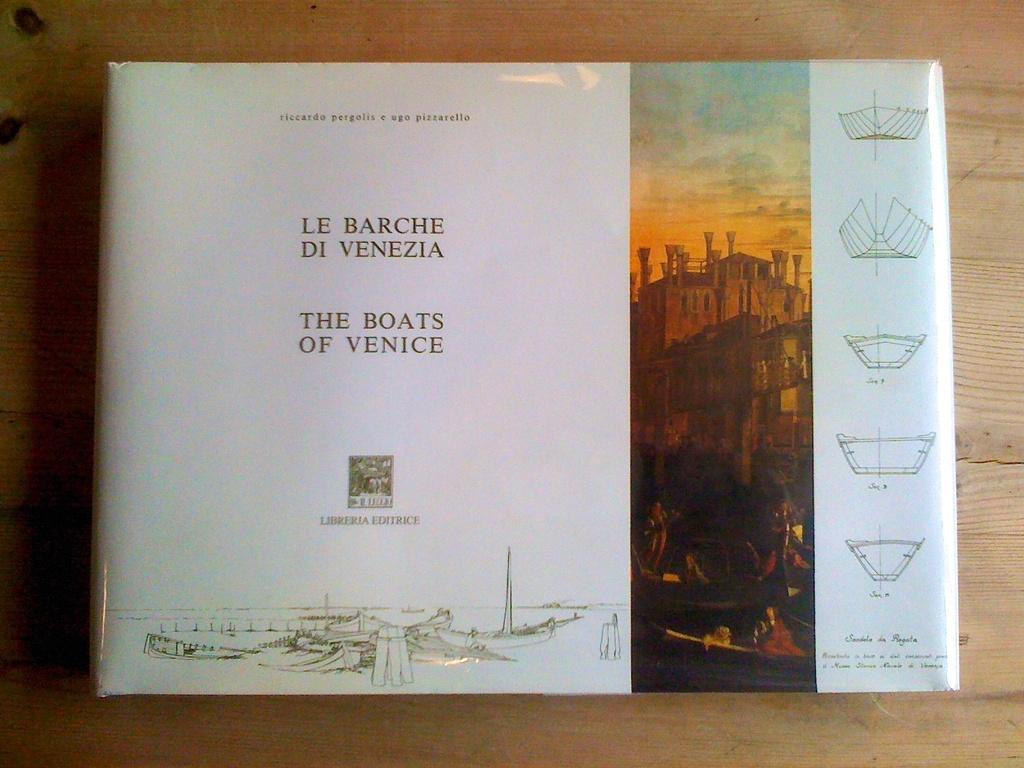What is the name of this book?
Provide a succinct answer. The boats of venice. Who wrote this book?
Offer a very short reply. Le barche di venezia. 